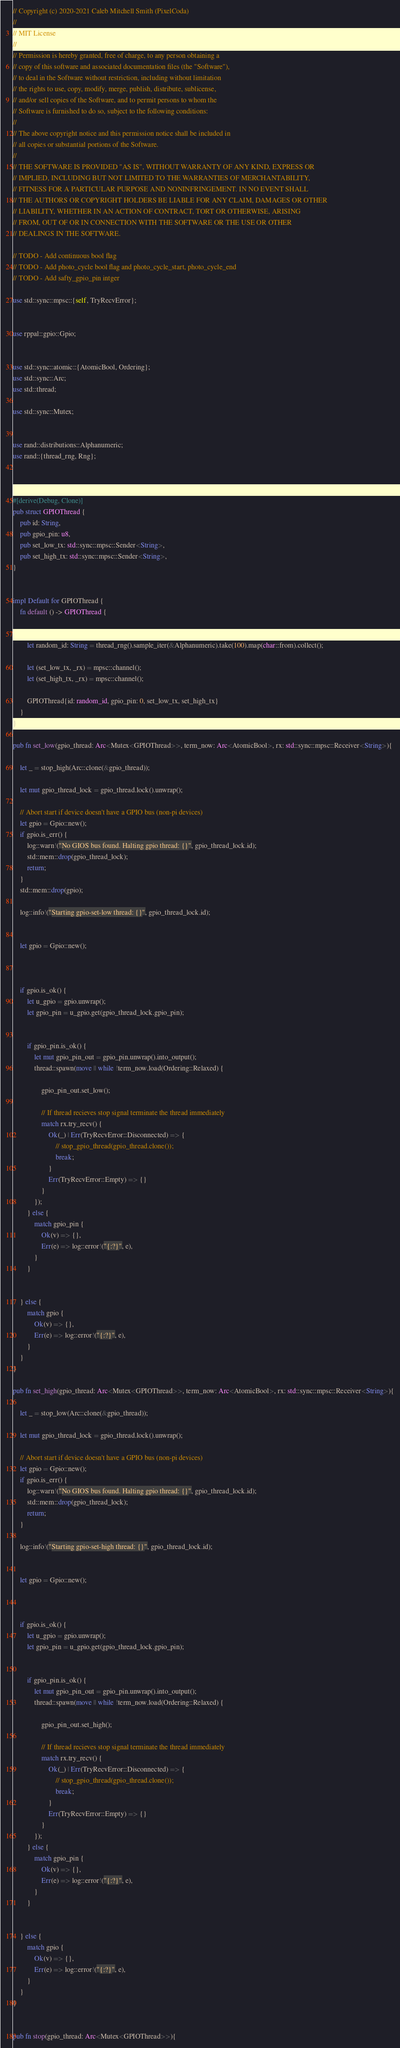<code> <loc_0><loc_0><loc_500><loc_500><_Rust_>// Copyright (c) 2020-2021 Caleb Mitchell Smith (PixelCoda)
//
// MIT License
//
// Permission is hereby granted, free of charge, to any person obtaining a
// copy of this software and associated documentation files (the "Software"),
// to deal in the Software without restriction, including without limitation
// the rights to use, copy, modify, merge, publish, distribute, sublicense,
// and/or sell copies of the Software, and to permit persons to whom the
// Software is furnished to do so, subject to the following conditions:
//
// The above copyright notice and this permission notice shall be included in
// all copies or substantial portions of the Software.
//
// THE SOFTWARE IS PROVIDED "AS IS", WITHOUT WARRANTY OF ANY KIND, EXPRESS OR
// IMPLIED, INCLUDING BUT NOT LIMITED TO THE WARRANTIES OF MERCHANTABILITY,
// FITNESS FOR A PARTICULAR PURPOSE AND NONINFRINGEMENT. IN NO EVENT SHALL
// THE AUTHORS OR COPYRIGHT HOLDERS BE LIABLE FOR ANY CLAIM, DAMAGES OR OTHER
// LIABILITY, WHETHER IN AN ACTION OF CONTRACT, TORT OR OTHERWISE, ARISING
// FROM, OUT OF OR IN CONNECTION WITH THE SOFTWARE OR THE USE OR OTHER
// DEALINGS IN THE SOFTWARE.

// TODO - Add continuous bool flag
// TODO - Add photo_cycle bool flag and photo_cycle_start, photo_cycle_end
// TODO - Add safty_gpio_pin intger

use std::sync::mpsc::{self, TryRecvError};


use rppal::gpio::Gpio;


use std::sync::atomic::{AtomicBool, Ordering};
use std::sync::Arc;
use std::thread;

use std::sync::Mutex;


use rand::distributions::Alphanumeric;
use rand::{thread_rng, Rng};



#[derive(Debug, Clone)]
pub struct GPIOThread {
    pub id: String,
    pub gpio_pin: u8,
    pub set_low_tx: std::sync::mpsc::Sender<String>,
    pub set_high_tx: std::sync::mpsc::Sender<String>,
}


impl Default for GPIOThread {
    fn default () -> GPIOThread {


        let random_id: String = thread_rng().sample_iter(&Alphanumeric).take(100).map(char::from).collect();

        let (set_low_tx, _rx) = mpsc::channel();
        let (set_high_tx, _rx) = mpsc::channel();

        GPIOThread{id: random_id, gpio_pin: 0, set_low_tx, set_high_tx}
    }
}

pub fn set_low(gpio_thread: Arc<Mutex<GPIOThread>>, term_now: Arc<AtomicBool>, rx: std::sync::mpsc::Receiver<String>){

    let _ = stop_high(Arc::clone(&gpio_thread));
    
    let mut gpio_thread_lock = gpio_thread.lock().unwrap();

    // Abort start if device doesn't have a GPIO bus (non-pi devices)
    let gpio = Gpio::new();
    if gpio.is_err() {
        log::warn!("No GIOS bus found. Halting gpio thread: {}", gpio_thread_lock.id);
        std::mem::drop(gpio_thread_lock);
        return;
    }
    std::mem::drop(gpio);

    log::info!("Starting gpio-set-low thread: {}", gpio_thread_lock.id);


    let gpio = Gpio::new();



    if gpio.is_ok() {
        let u_gpio = gpio.unwrap();
        let gpio_pin = u_gpio.get(gpio_thread_lock.gpio_pin);
        

        if gpio_pin.is_ok() {
            let mut gpio_pin_out = gpio_pin.unwrap().into_output();
            thread::spawn(move || while !term_now.load(Ordering::Relaxed) {

                gpio_pin_out.set_low();
                
                // If thread recieves stop signal terminate the thread immediately
                match rx.try_recv() {
                    Ok(_) | Err(TryRecvError::Disconnected) => {
                        // stop_gpio_thread(gpio_thread.clone());
                        break;
                    }
                    Err(TryRecvError::Empty) => {}
                }
            });
        } else {
            match gpio_pin {
                Ok(v) => {},
                Err(e) => log::error!("{:?}", e),
            }
        }
 

    } else {
        match gpio {
            Ok(v) => {},
            Err(e) => log::error!("{:?}", e),
        }
    }
}

pub fn set_high(gpio_thread: Arc<Mutex<GPIOThread>>, term_now: Arc<AtomicBool>, rx: std::sync::mpsc::Receiver<String>){

    let _ = stop_low(Arc::clone(&gpio_thread));

    let mut gpio_thread_lock = gpio_thread.lock().unwrap();

    // Abort start if device doesn't have a GPIO bus (non-pi devices)
    let gpio = Gpio::new();
    if gpio.is_err() {
        log::warn!("No GIOS bus found. Halting gpio thread: {}", gpio_thread_lock.id);
        std::mem::drop(gpio_thread_lock);
        return;
    }

    log::info!("Starting gpio-set-high thread: {}", gpio_thread_lock.id);


    let gpio = Gpio::new();



    if gpio.is_ok() {
        let u_gpio = gpio.unwrap();
        let gpio_pin = u_gpio.get(gpio_thread_lock.gpio_pin);
        

        if gpio_pin.is_ok() {
            let mut gpio_pin_out = gpio_pin.unwrap().into_output();
            thread::spawn(move || while !term_now.load(Ordering::Relaxed) {

                gpio_pin_out.set_high();
                
                // If thread recieves stop signal terminate the thread immediately
                match rx.try_recv() {
                    Ok(_) | Err(TryRecvError::Disconnected) => {
                        // stop_gpio_thread(gpio_thread.clone());
                        break;
                    }
                    Err(TryRecvError::Empty) => {}
                }
            });
        } else {
            match gpio_pin {
                Ok(v) => {},
                Err(e) => log::error!("{:?}", e),
            }
        }
 

    } else {
        match gpio {
            Ok(v) => {},
            Err(e) => log::error!("{:?}", e),
        }
    }
}


pub fn stop(gpio_thread: Arc<Mutex<GPIOThread>>){</code> 